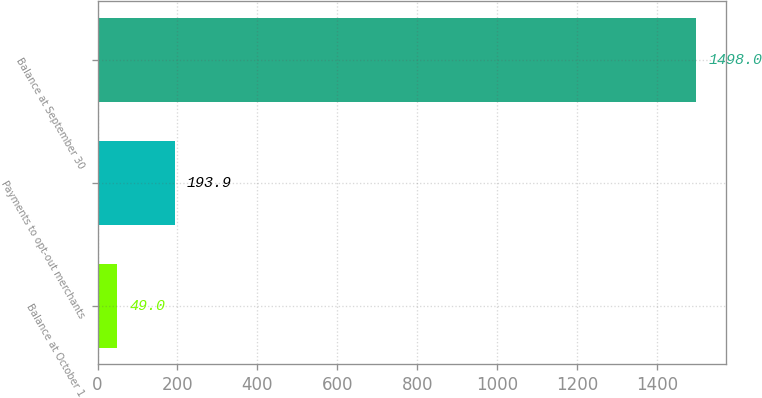Convert chart to OTSL. <chart><loc_0><loc_0><loc_500><loc_500><bar_chart><fcel>Balance at October 1<fcel>Payments to opt-out merchants<fcel>Balance at September 30<nl><fcel>49<fcel>193.9<fcel>1498<nl></chart> 